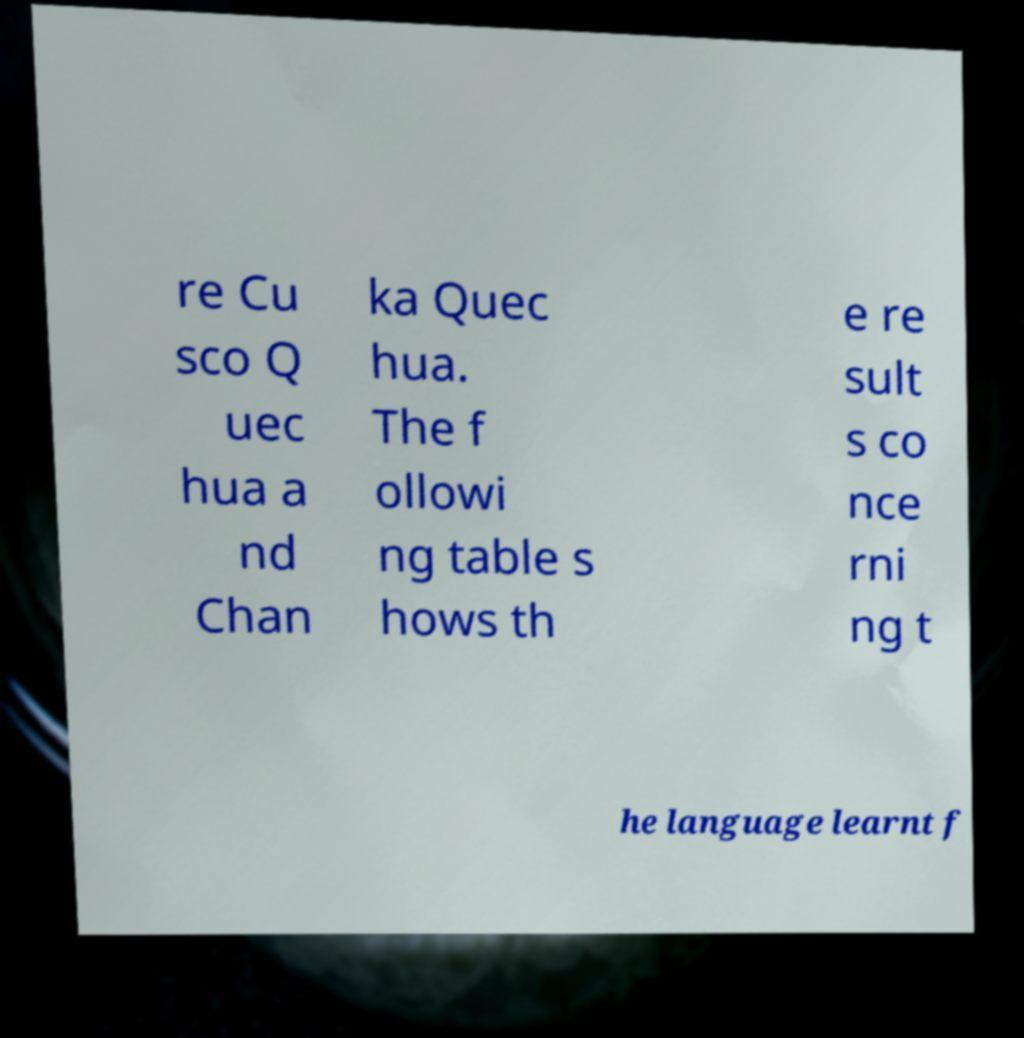What messages or text are displayed in this image? I need them in a readable, typed format. re Cu sco Q uec hua a nd Chan ka Quec hua. The f ollowi ng table s hows th e re sult s co nce rni ng t he language learnt f 